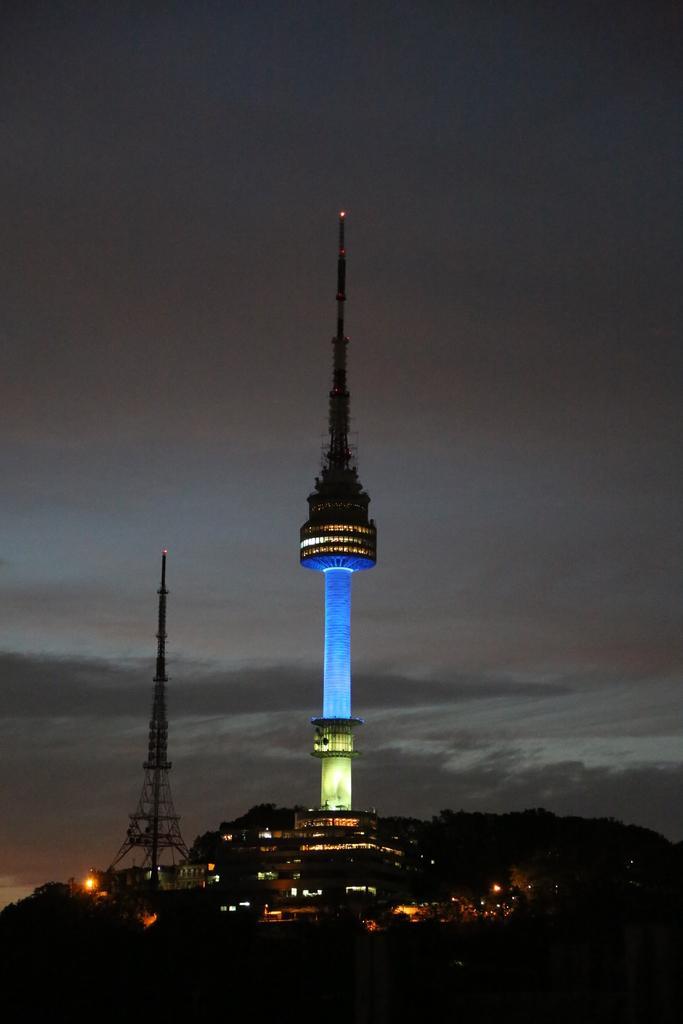Could you give a brief overview of what you see in this image? In the picture we can see a city with lights in the dark and a pole building with some floors to it and inside we can see the Eiffel tower and in the background we can see a sky with clouds. 